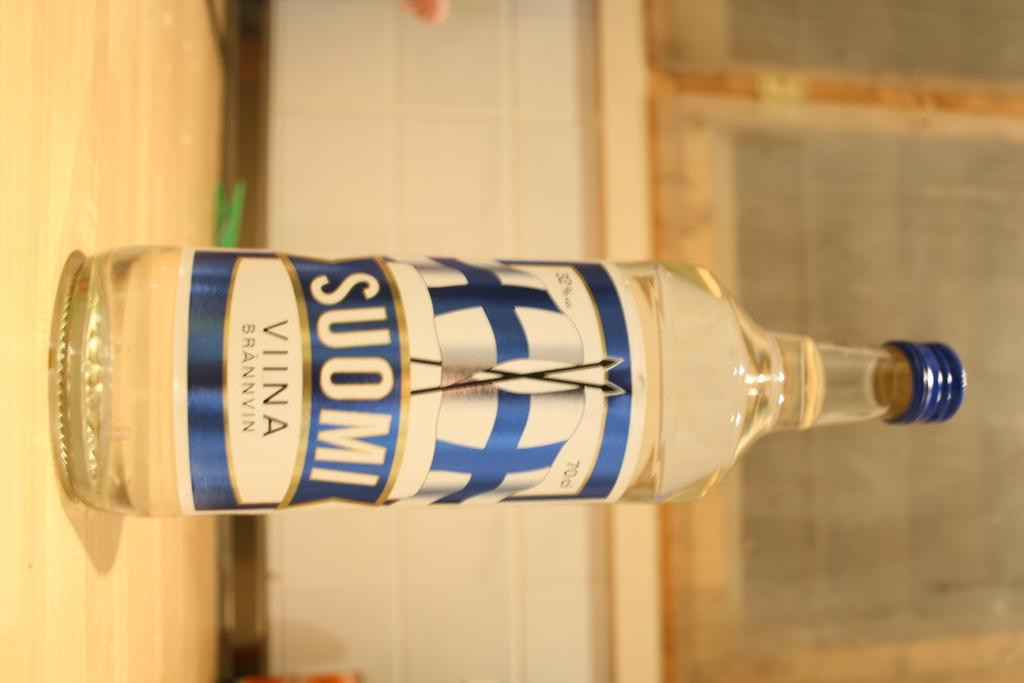What object is placed on the table in the image? There is a bottle on a table in the image. What can be seen on or near the windows in the image? There are windows with mesh in the image. How many goldfish are swimming in the bottle in the image? There are no goldfish present in the image; it only features a bottle on a table. What type of badge is visible on the person in the image? There is no person present in the image, so it is not possible to determine if there is a badge or not. 